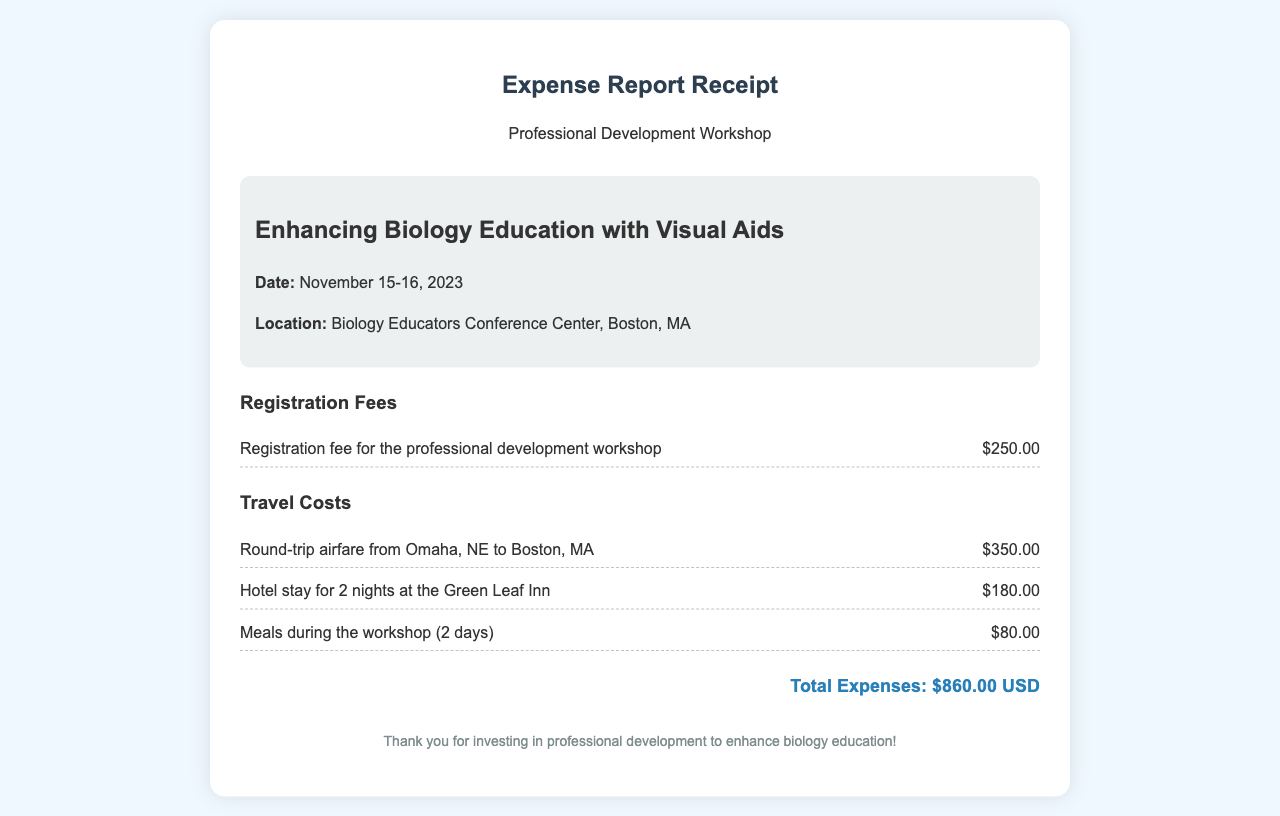What is the date of the workshop? The date of the workshop is specified in the document as November 15-16, 2023.
Answer: November 15-16, 2023 Where is the workshop located? The location of the workshop is mentioned as the Biology Educators Conference Center, Boston, MA.
Answer: Biology Educators Conference Center, Boston, MA What is the total expense amount listed? The total expenses are calculated at the end of the document, which is $860.00 USD.
Answer: $860.00 USD How much was spent on airfare? The document lists the airfare cost specifically as $350.00.
Answer: $350.00 What is the registration fee for the workshop? The registration fee is stated in the expense report as $250.00.
Answer: $250.00 How many nights was the hotel stay? The hotel stay duration is mentioned as 2 nights in the document.
Answer: 2 nights What are the total meal costs during the workshop? The meal costs for 2 days are detailed as amounting to $80.00.
Answer: $80.00 What type of educational aid is highlighted in the workshop? The workshop emphasizes the integration of visual aids in biology education.
Answer: visual aids What sentiment is expressed at the end of the receipt? The footer expresses gratitude for investment in professional development for biology education.
Answer: Thank you for investing in professional development to enhance biology education! 